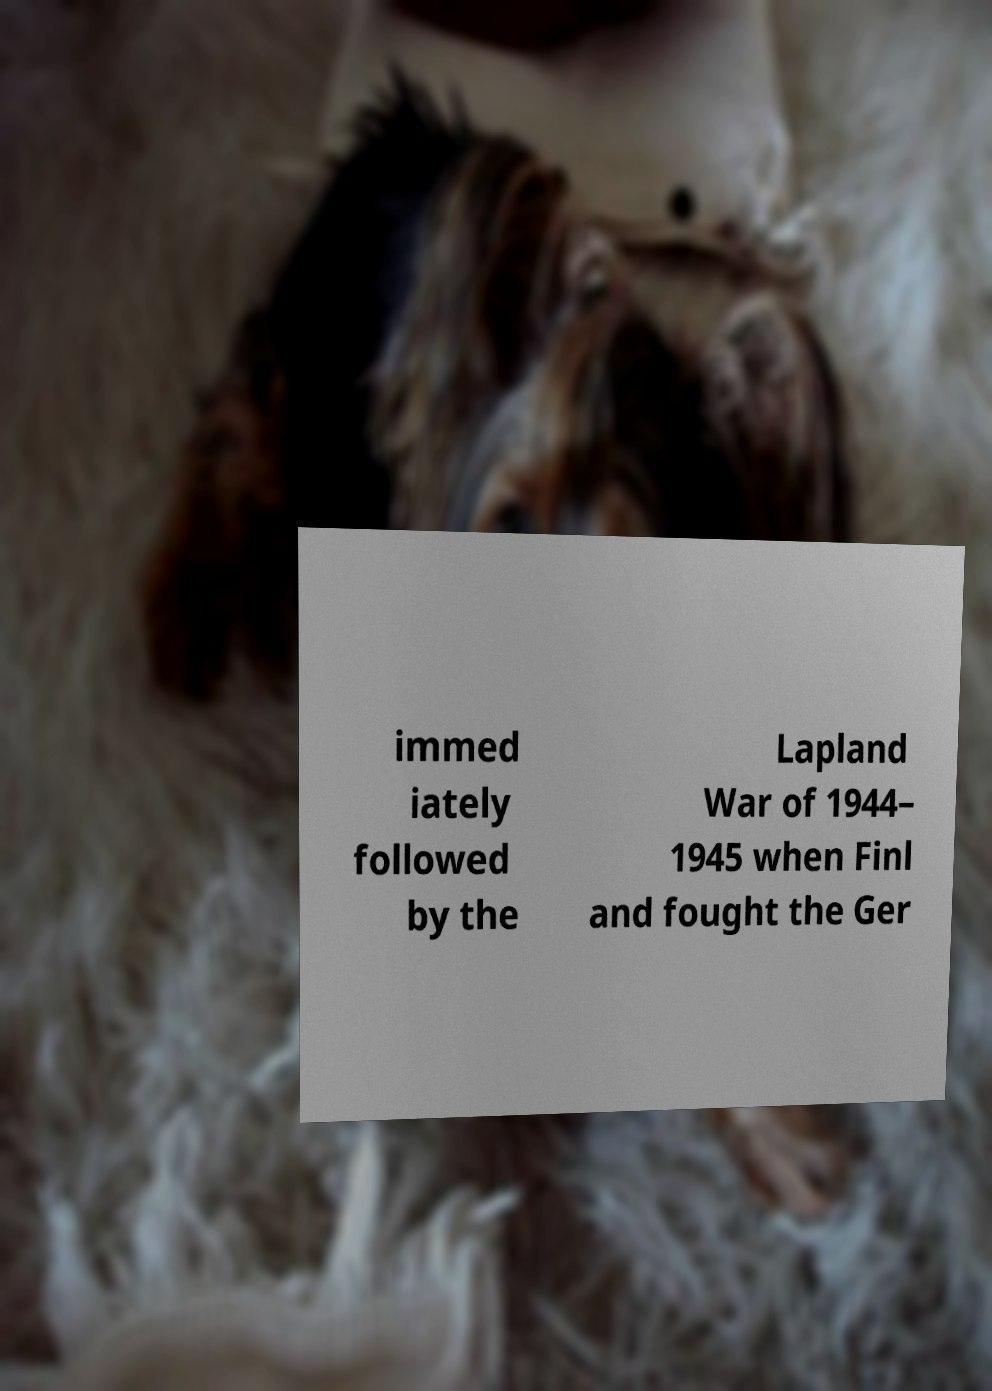Please identify and transcribe the text found in this image. immed iately followed by the Lapland War of 1944– 1945 when Finl and fought the Ger 